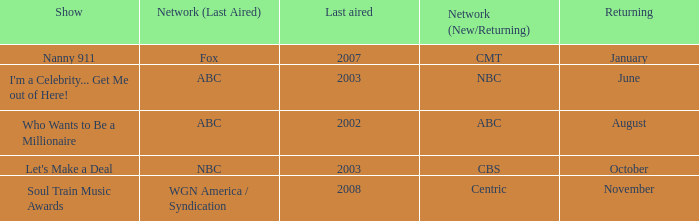What show was played on ABC laster after 2002? I'm a Celebrity... Get Me out of Here!. 